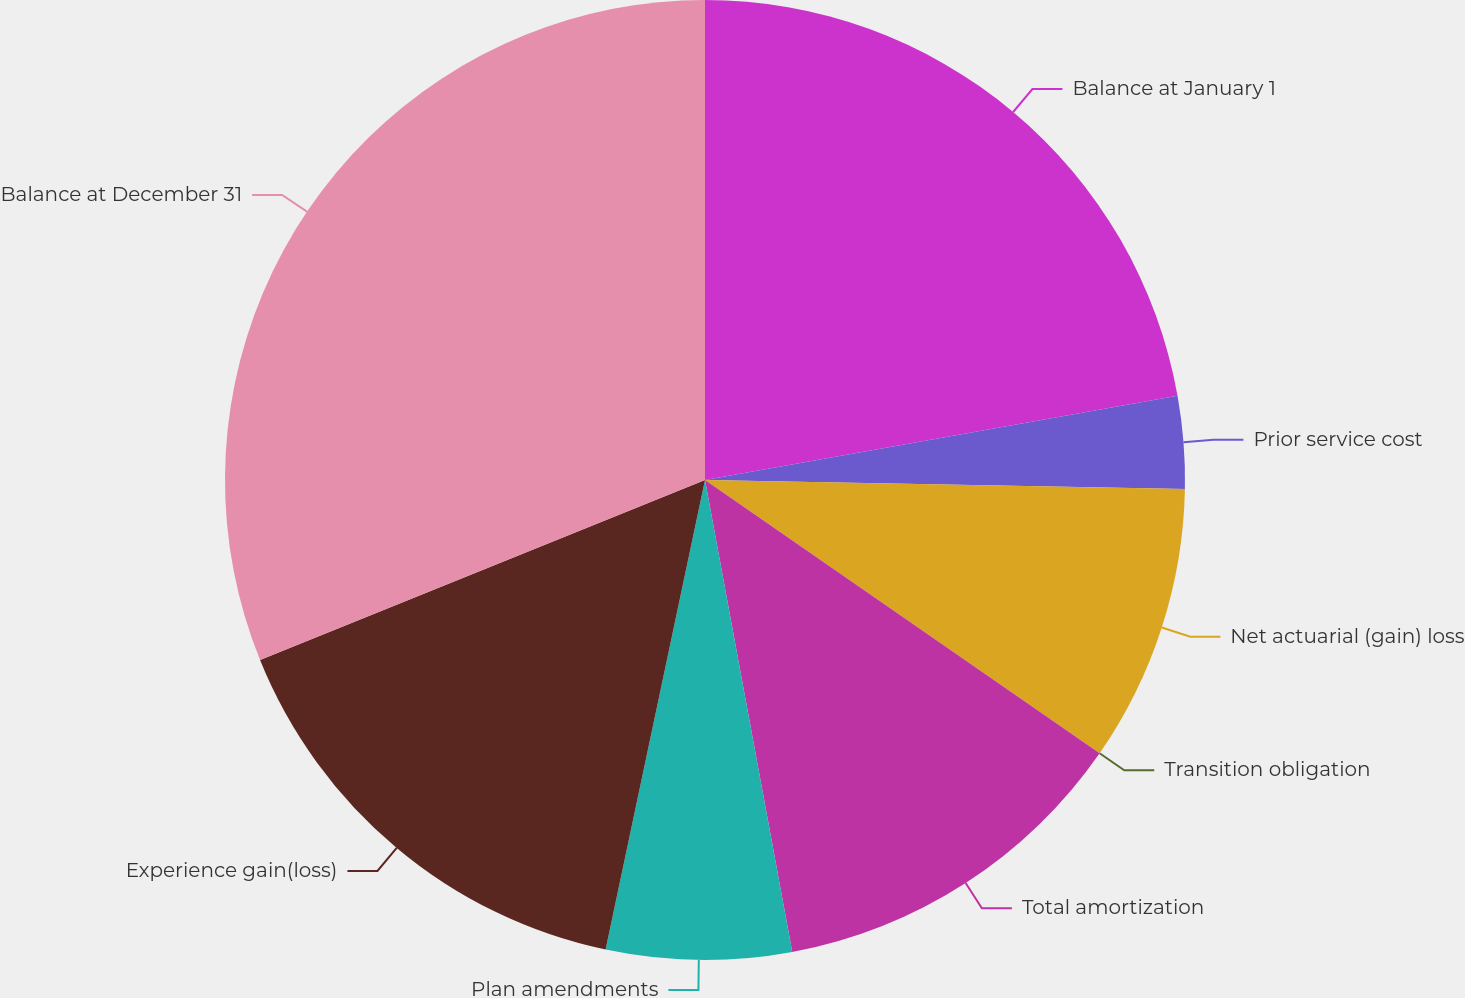Convert chart to OTSL. <chart><loc_0><loc_0><loc_500><loc_500><pie_chart><fcel>Balance at January 1<fcel>Prior service cost<fcel>Net actuarial (gain) loss<fcel>Transition obligation<fcel>Total amortization<fcel>Plan amendments<fcel>Experience gain(loss)<fcel>Balance at December 31<nl><fcel>22.19%<fcel>3.11%<fcel>9.34%<fcel>0.0%<fcel>12.45%<fcel>6.23%<fcel>15.56%<fcel>31.12%<nl></chart> 